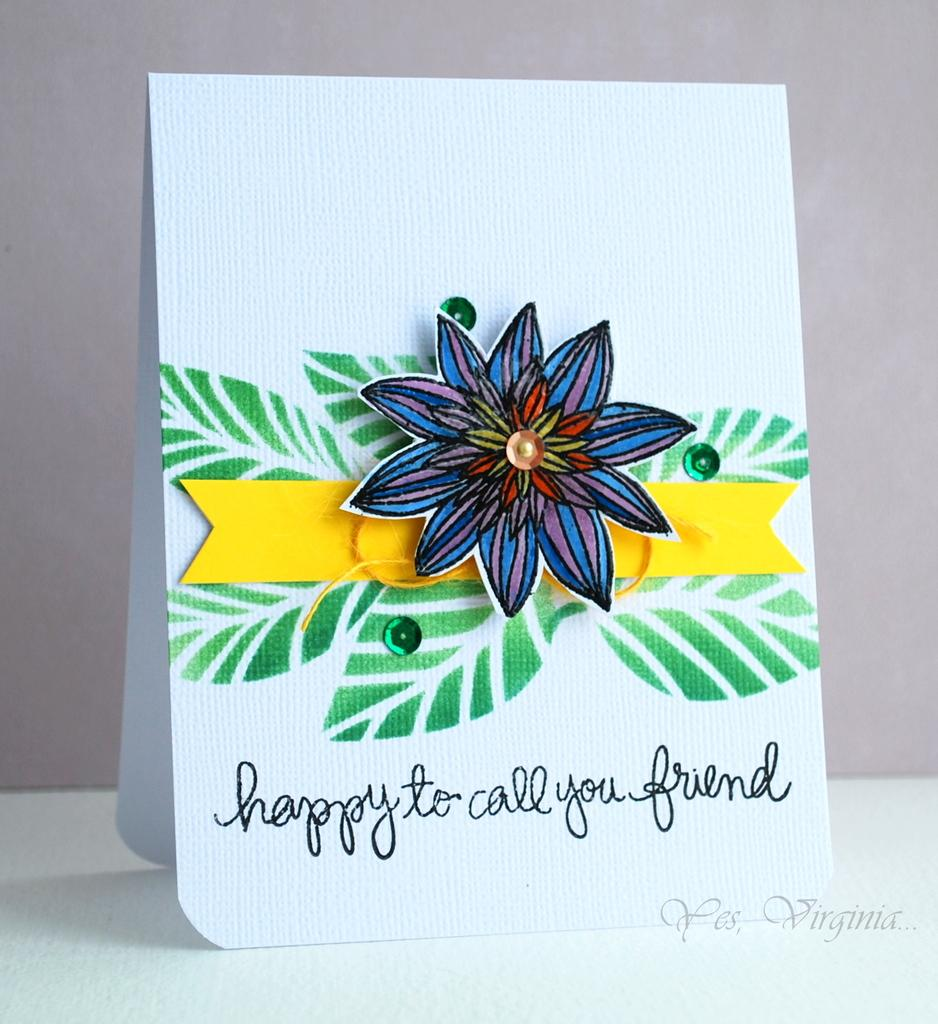What is the main subject of the image? The main subject of the image is a sheet. What is depicted on the sheet? The sheet has a flower and leaves drawn on it. Is there any text on the sheet? Yes, there is writing below the drawings on the sheet. How far away is the owl from the farm in the image? There is no owl or farm present in the image; it only features a sheet with drawings and writing. 